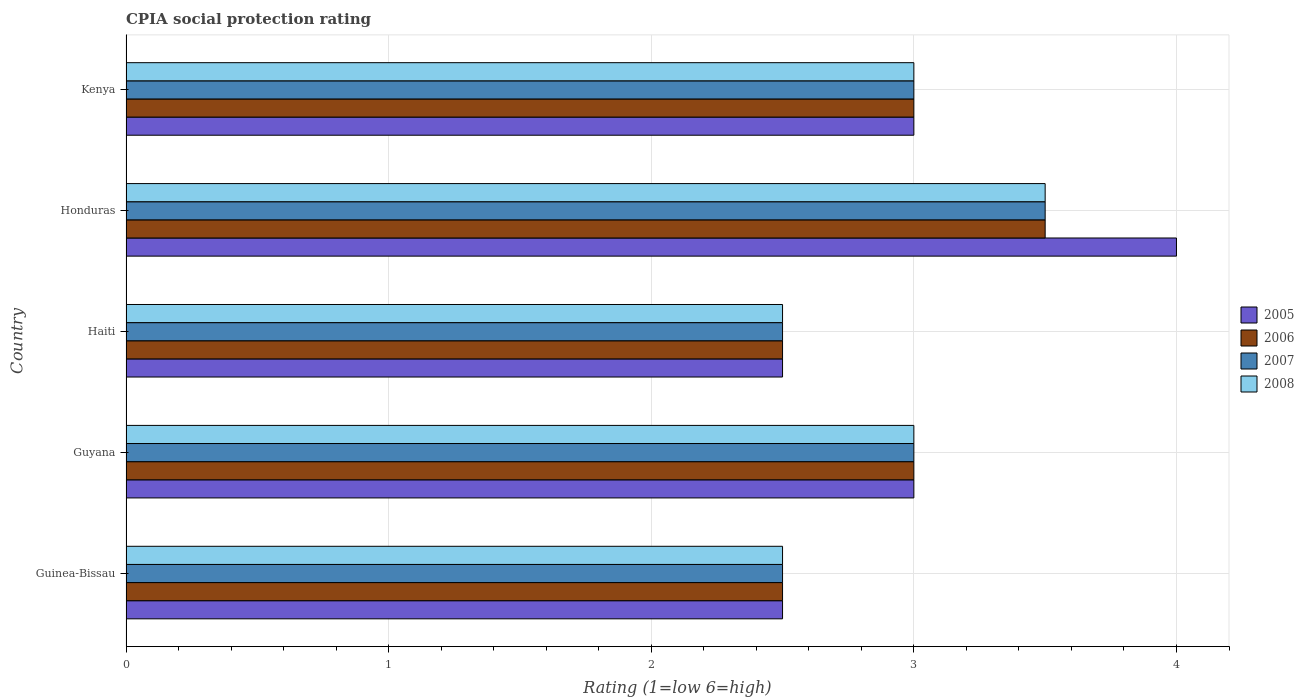How many different coloured bars are there?
Keep it short and to the point. 4. Are the number of bars per tick equal to the number of legend labels?
Ensure brevity in your answer.  Yes. How many bars are there on the 5th tick from the top?
Offer a very short reply. 4. How many bars are there on the 5th tick from the bottom?
Give a very brief answer. 4. What is the label of the 4th group of bars from the top?
Make the answer very short. Guyana. In how many cases, is the number of bars for a given country not equal to the number of legend labels?
Provide a short and direct response. 0. What is the CPIA rating in 2005 in Kenya?
Provide a short and direct response. 3. In which country was the CPIA rating in 2007 maximum?
Provide a short and direct response. Honduras. In which country was the CPIA rating in 2007 minimum?
Offer a very short reply. Guinea-Bissau. What is the average CPIA rating in 2006 per country?
Offer a terse response. 2.9. In how many countries, is the CPIA rating in 2005 greater than 3.8 ?
Provide a succinct answer. 1. Is the CPIA rating in 2007 in Guinea-Bissau less than that in Haiti?
Offer a terse response. No. What is the difference between the highest and the second highest CPIA rating in 2008?
Offer a terse response. 0.5. In how many countries, is the CPIA rating in 2005 greater than the average CPIA rating in 2005 taken over all countries?
Ensure brevity in your answer.  1. What does the 1st bar from the bottom in Honduras represents?
Make the answer very short. 2005. Is it the case that in every country, the sum of the CPIA rating in 2006 and CPIA rating in 2008 is greater than the CPIA rating in 2007?
Offer a very short reply. Yes. How many bars are there?
Your response must be concise. 20. How many countries are there in the graph?
Offer a terse response. 5. Does the graph contain any zero values?
Your answer should be very brief. No. How many legend labels are there?
Offer a very short reply. 4. How are the legend labels stacked?
Your answer should be very brief. Vertical. What is the title of the graph?
Your answer should be compact. CPIA social protection rating. What is the label or title of the Y-axis?
Offer a terse response. Country. What is the Rating (1=low 6=high) in 2005 in Guinea-Bissau?
Provide a short and direct response. 2.5. What is the Rating (1=low 6=high) of 2006 in Guinea-Bissau?
Offer a terse response. 2.5. What is the Rating (1=low 6=high) in 2005 in Guyana?
Your answer should be compact. 3. What is the Rating (1=low 6=high) of 2006 in Guyana?
Your answer should be very brief. 3. What is the Rating (1=low 6=high) of 2007 in Guyana?
Offer a terse response. 3. What is the Rating (1=low 6=high) of 2008 in Guyana?
Your response must be concise. 3. What is the Rating (1=low 6=high) of 2005 in Haiti?
Give a very brief answer. 2.5. What is the Rating (1=low 6=high) of 2007 in Haiti?
Offer a very short reply. 2.5. What is the Rating (1=low 6=high) of 2005 in Honduras?
Offer a very short reply. 4. What is the Rating (1=low 6=high) of 2008 in Honduras?
Ensure brevity in your answer.  3.5. What is the Rating (1=low 6=high) of 2005 in Kenya?
Your answer should be very brief. 3. What is the Rating (1=low 6=high) in 2006 in Kenya?
Make the answer very short. 3. What is the Rating (1=low 6=high) in 2008 in Kenya?
Offer a very short reply. 3. Across all countries, what is the maximum Rating (1=low 6=high) in 2006?
Your answer should be compact. 3.5. Across all countries, what is the maximum Rating (1=low 6=high) of 2007?
Keep it short and to the point. 3.5. Across all countries, what is the minimum Rating (1=low 6=high) of 2006?
Keep it short and to the point. 2.5. Across all countries, what is the minimum Rating (1=low 6=high) of 2007?
Your answer should be compact. 2.5. Across all countries, what is the minimum Rating (1=low 6=high) in 2008?
Provide a succinct answer. 2.5. What is the total Rating (1=low 6=high) in 2005 in the graph?
Give a very brief answer. 15. What is the total Rating (1=low 6=high) of 2006 in the graph?
Your answer should be compact. 14.5. What is the total Rating (1=low 6=high) of 2008 in the graph?
Give a very brief answer. 14.5. What is the difference between the Rating (1=low 6=high) in 2005 in Guinea-Bissau and that in Guyana?
Your response must be concise. -0.5. What is the difference between the Rating (1=low 6=high) in 2006 in Guinea-Bissau and that in Guyana?
Give a very brief answer. -0.5. What is the difference between the Rating (1=low 6=high) in 2008 in Guinea-Bissau and that in Guyana?
Provide a short and direct response. -0.5. What is the difference between the Rating (1=low 6=high) in 2006 in Guinea-Bissau and that in Haiti?
Provide a succinct answer. 0. What is the difference between the Rating (1=low 6=high) in 2007 in Guinea-Bissau and that in Haiti?
Ensure brevity in your answer.  0. What is the difference between the Rating (1=low 6=high) in 2008 in Guinea-Bissau and that in Kenya?
Your response must be concise. -0.5. What is the difference between the Rating (1=low 6=high) in 2005 in Guyana and that in Haiti?
Your answer should be very brief. 0.5. What is the difference between the Rating (1=low 6=high) of 2006 in Guyana and that in Haiti?
Provide a succinct answer. 0.5. What is the difference between the Rating (1=low 6=high) of 2007 in Guyana and that in Haiti?
Keep it short and to the point. 0.5. What is the difference between the Rating (1=low 6=high) in 2006 in Guyana and that in Honduras?
Provide a succinct answer. -0.5. What is the difference between the Rating (1=low 6=high) in 2007 in Guyana and that in Honduras?
Keep it short and to the point. -0.5. What is the difference between the Rating (1=low 6=high) in 2006 in Guyana and that in Kenya?
Ensure brevity in your answer.  0. What is the difference between the Rating (1=low 6=high) in 2008 in Guyana and that in Kenya?
Ensure brevity in your answer.  0. What is the difference between the Rating (1=low 6=high) in 2006 in Haiti and that in Honduras?
Offer a terse response. -1. What is the difference between the Rating (1=low 6=high) of 2007 in Haiti and that in Honduras?
Your response must be concise. -1. What is the difference between the Rating (1=low 6=high) in 2008 in Haiti and that in Honduras?
Make the answer very short. -1. What is the difference between the Rating (1=low 6=high) of 2006 in Haiti and that in Kenya?
Provide a succinct answer. -0.5. What is the difference between the Rating (1=low 6=high) of 2007 in Haiti and that in Kenya?
Your response must be concise. -0.5. What is the difference between the Rating (1=low 6=high) of 2008 in Haiti and that in Kenya?
Your answer should be compact. -0.5. What is the difference between the Rating (1=low 6=high) in 2005 in Honduras and that in Kenya?
Make the answer very short. 1. What is the difference between the Rating (1=low 6=high) of 2005 in Guinea-Bissau and the Rating (1=low 6=high) of 2007 in Guyana?
Your answer should be very brief. -0.5. What is the difference between the Rating (1=low 6=high) of 2006 in Guinea-Bissau and the Rating (1=low 6=high) of 2008 in Guyana?
Give a very brief answer. -0.5. What is the difference between the Rating (1=low 6=high) of 2005 in Guinea-Bissau and the Rating (1=low 6=high) of 2006 in Haiti?
Make the answer very short. 0. What is the difference between the Rating (1=low 6=high) of 2005 in Guinea-Bissau and the Rating (1=low 6=high) of 2007 in Haiti?
Offer a very short reply. 0. What is the difference between the Rating (1=low 6=high) of 2005 in Guinea-Bissau and the Rating (1=low 6=high) of 2008 in Haiti?
Your answer should be very brief. 0. What is the difference between the Rating (1=low 6=high) of 2005 in Guinea-Bissau and the Rating (1=low 6=high) of 2007 in Honduras?
Provide a short and direct response. -1. What is the difference between the Rating (1=low 6=high) of 2006 in Guinea-Bissau and the Rating (1=low 6=high) of 2007 in Honduras?
Give a very brief answer. -1. What is the difference between the Rating (1=low 6=high) in 2006 in Guinea-Bissau and the Rating (1=low 6=high) in 2007 in Kenya?
Make the answer very short. -0.5. What is the difference between the Rating (1=low 6=high) in 2007 in Guinea-Bissau and the Rating (1=low 6=high) in 2008 in Kenya?
Provide a succinct answer. -0.5. What is the difference between the Rating (1=low 6=high) of 2005 in Guyana and the Rating (1=low 6=high) of 2008 in Haiti?
Your answer should be compact. 0.5. What is the difference between the Rating (1=low 6=high) of 2006 in Guyana and the Rating (1=low 6=high) of 2007 in Haiti?
Offer a terse response. 0.5. What is the difference between the Rating (1=low 6=high) in 2005 in Guyana and the Rating (1=low 6=high) in 2008 in Honduras?
Offer a very short reply. -0.5. What is the difference between the Rating (1=low 6=high) in 2006 in Guyana and the Rating (1=low 6=high) in 2007 in Honduras?
Give a very brief answer. -0.5. What is the difference between the Rating (1=low 6=high) of 2006 in Guyana and the Rating (1=low 6=high) of 2008 in Honduras?
Provide a short and direct response. -0.5. What is the difference between the Rating (1=low 6=high) in 2005 in Guyana and the Rating (1=low 6=high) in 2007 in Kenya?
Your answer should be compact. 0. What is the difference between the Rating (1=low 6=high) in 2006 in Guyana and the Rating (1=low 6=high) in 2007 in Kenya?
Your answer should be compact. 0. What is the difference between the Rating (1=low 6=high) in 2007 in Guyana and the Rating (1=low 6=high) in 2008 in Kenya?
Offer a terse response. 0. What is the difference between the Rating (1=low 6=high) of 2005 in Haiti and the Rating (1=low 6=high) of 2007 in Honduras?
Your answer should be compact. -1. What is the difference between the Rating (1=low 6=high) of 2005 in Haiti and the Rating (1=low 6=high) of 2008 in Honduras?
Give a very brief answer. -1. What is the difference between the Rating (1=low 6=high) in 2006 in Haiti and the Rating (1=low 6=high) in 2007 in Honduras?
Give a very brief answer. -1. What is the difference between the Rating (1=low 6=high) of 2005 in Haiti and the Rating (1=low 6=high) of 2006 in Kenya?
Keep it short and to the point. -0.5. What is the difference between the Rating (1=low 6=high) in 2006 in Haiti and the Rating (1=low 6=high) in 2008 in Kenya?
Keep it short and to the point. -0.5. What is the difference between the Rating (1=low 6=high) in 2005 in Honduras and the Rating (1=low 6=high) in 2006 in Kenya?
Make the answer very short. 1. What is the difference between the Rating (1=low 6=high) in 2005 in Honduras and the Rating (1=low 6=high) in 2007 in Kenya?
Your response must be concise. 1. What is the difference between the Rating (1=low 6=high) in 2006 in Honduras and the Rating (1=low 6=high) in 2008 in Kenya?
Keep it short and to the point. 0.5. What is the average Rating (1=low 6=high) in 2005 per country?
Ensure brevity in your answer.  3. What is the average Rating (1=low 6=high) of 2006 per country?
Your response must be concise. 2.9. What is the difference between the Rating (1=low 6=high) of 2005 and Rating (1=low 6=high) of 2006 in Guinea-Bissau?
Offer a terse response. 0. What is the difference between the Rating (1=low 6=high) in 2005 and Rating (1=low 6=high) in 2007 in Guinea-Bissau?
Make the answer very short. 0. What is the difference between the Rating (1=low 6=high) of 2005 and Rating (1=low 6=high) of 2008 in Guyana?
Make the answer very short. 0. What is the difference between the Rating (1=low 6=high) in 2006 and Rating (1=low 6=high) in 2007 in Guyana?
Your response must be concise. 0. What is the difference between the Rating (1=low 6=high) of 2005 and Rating (1=low 6=high) of 2006 in Haiti?
Give a very brief answer. 0. What is the difference between the Rating (1=low 6=high) in 2005 and Rating (1=low 6=high) in 2007 in Haiti?
Your answer should be very brief. 0. What is the difference between the Rating (1=low 6=high) in 2005 and Rating (1=low 6=high) in 2008 in Haiti?
Your response must be concise. 0. What is the difference between the Rating (1=low 6=high) in 2005 and Rating (1=low 6=high) in 2006 in Honduras?
Your answer should be very brief. 0.5. What is the difference between the Rating (1=low 6=high) of 2005 and Rating (1=low 6=high) of 2008 in Honduras?
Make the answer very short. 0.5. What is the difference between the Rating (1=low 6=high) in 2006 and Rating (1=low 6=high) in 2007 in Honduras?
Your answer should be compact. 0. What is the difference between the Rating (1=low 6=high) of 2007 and Rating (1=low 6=high) of 2008 in Honduras?
Your response must be concise. 0. What is the difference between the Rating (1=low 6=high) in 2005 and Rating (1=low 6=high) in 2007 in Kenya?
Offer a very short reply. 0. What is the difference between the Rating (1=low 6=high) of 2005 and Rating (1=low 6=high) of 2008 in Kenya?
Your answer should be very brief. 0. What is the difference between the Rating (1=low 6=high) in 2006 and Rating (1=low 6=high) in 2007 in Kenya?
Keep it short and to the point. 0. What is the difference between the Rating (1=low 6=high) in 2006 and Rating (1=low 6=high) in 2008 in Kenya?
Offer a very short reply. 0. What is the ratio of the Rating (1=low 6=high) of 2008 in Guinea-Bissau to that in Haiti?
Give a very brief answer. 1. What is the ratio of the Rating (1=low 6=high) of 2006 in Guinea-Bissau to that in Honduras?
Give a very brief answer. 0.71. What is the ratio of the Rating (1=low 6=high) of 2006 in Guinea-Bissau to that in Kenya?
Your answer should be compact. 0.83. What is the ratio of the Rating (1=low 6=high) in 2005 in Guyana to that in Haiti?
Offer a very short reply. 1.2. What is the ratio of the Rating (1=low 6=high) in 2008 in Guyana to that in Haiti?
Make the answer very short. 1.2. What is the ratio of the Rating (1=low 6=high) in 2007 in Guyana to that in Honduras?
Make the answer very short. 0.86. What is the ratio of the Rating (1=low 6=high) of 2008 in Guyana to that in Honduras?
Offer a terse response. 0.86. What is the ratio of the Rating (1=low 6=high) in 2008 in Guyana to that in Kenya?
Your answer should be compact. 1. What is the ratio of the Rating (1=low 6=high) of 2008 in Haiti to that in Honduras?
Give a very brief answer. 0.71. What is the ratio of the Rating (1=low 6=high) in 2006 in Haiti to that in Kenya?
Your answer should be compact. 0.83. What is the difference between the highest and the second highest Rating (1=low 6=high) in 2006?
Ensure brevity in your answer.  0.5. What is the difference between the highest and the second highest Rating (1=low 6=high) in 2008?
Your response must be concise. 0.5. What is the difference between the highest and the lowest Rating (1=low 6=high) of 2006?
Your answer should be compact. 1. What is the difference between the highest and the lowest Rating (1=low 6=high) in 2008?
Give a very brief answer. 1. 